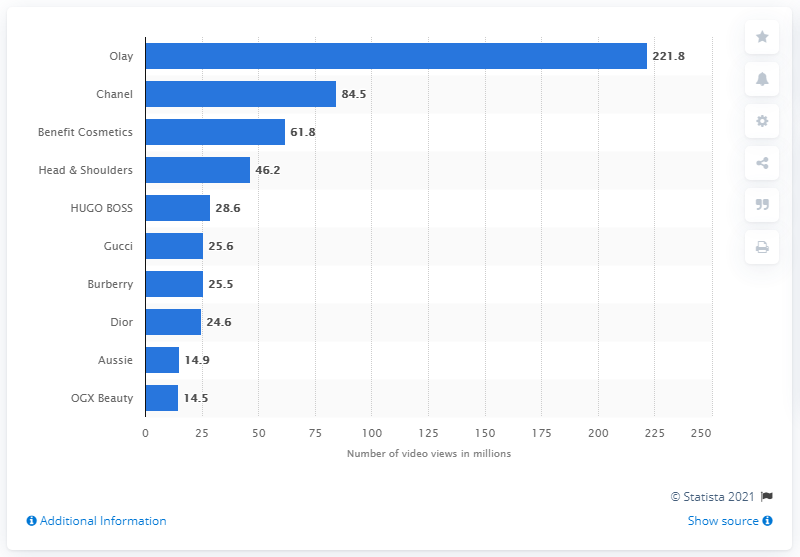Outline some significant characteristics in this image. During the survey period, Olay had 221.8 video views on Facebook. 